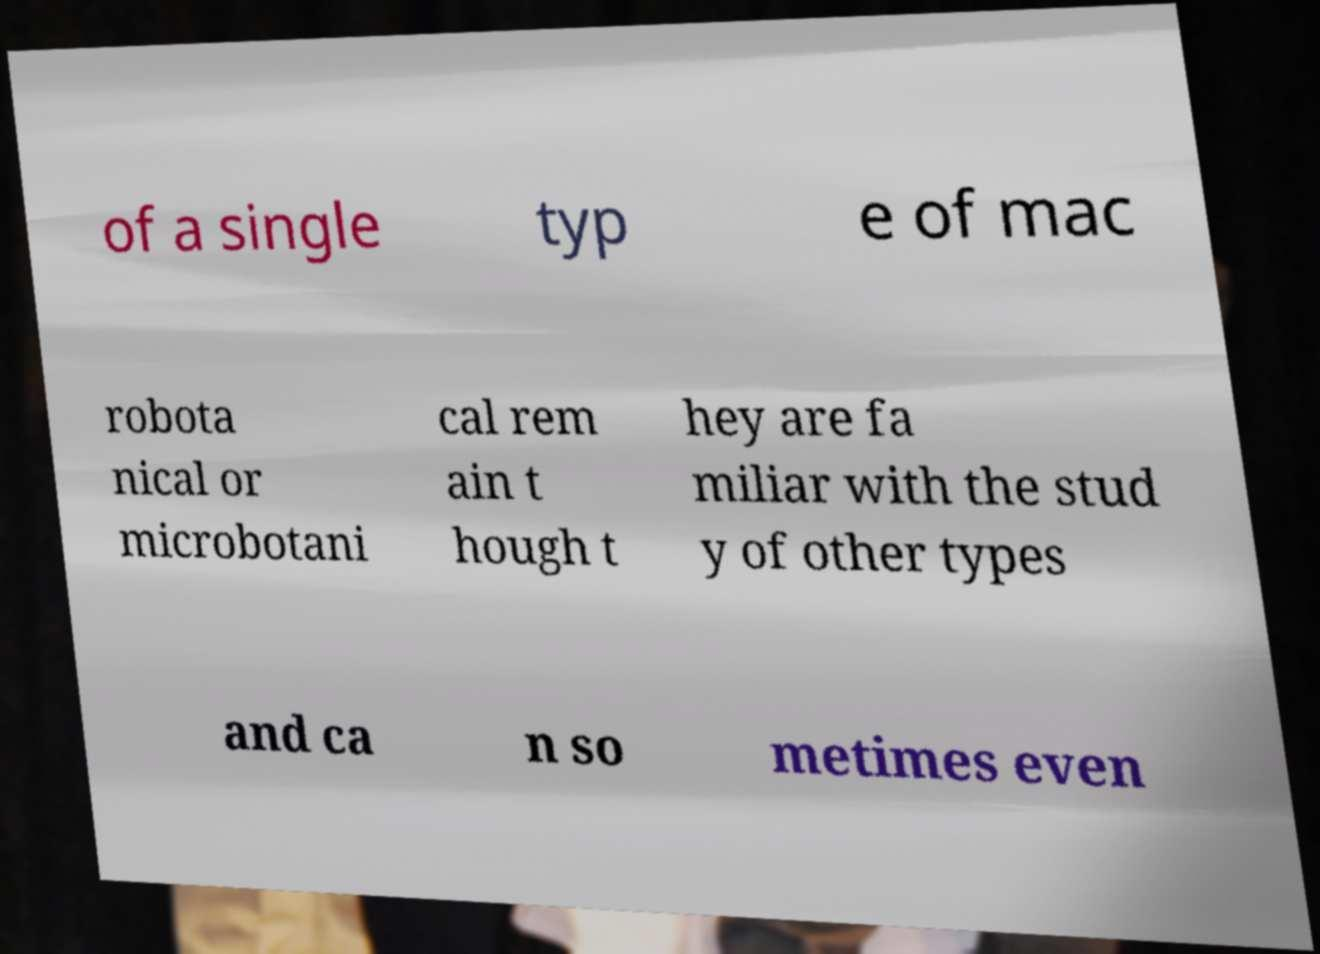Could you assist in decoding the text presented in this image and type it out clearly? of a single typ e of mac robota nical or microbotani cal rem ain t hough t hey are fa miliar with the stud y of other types and ca n so metimes even 